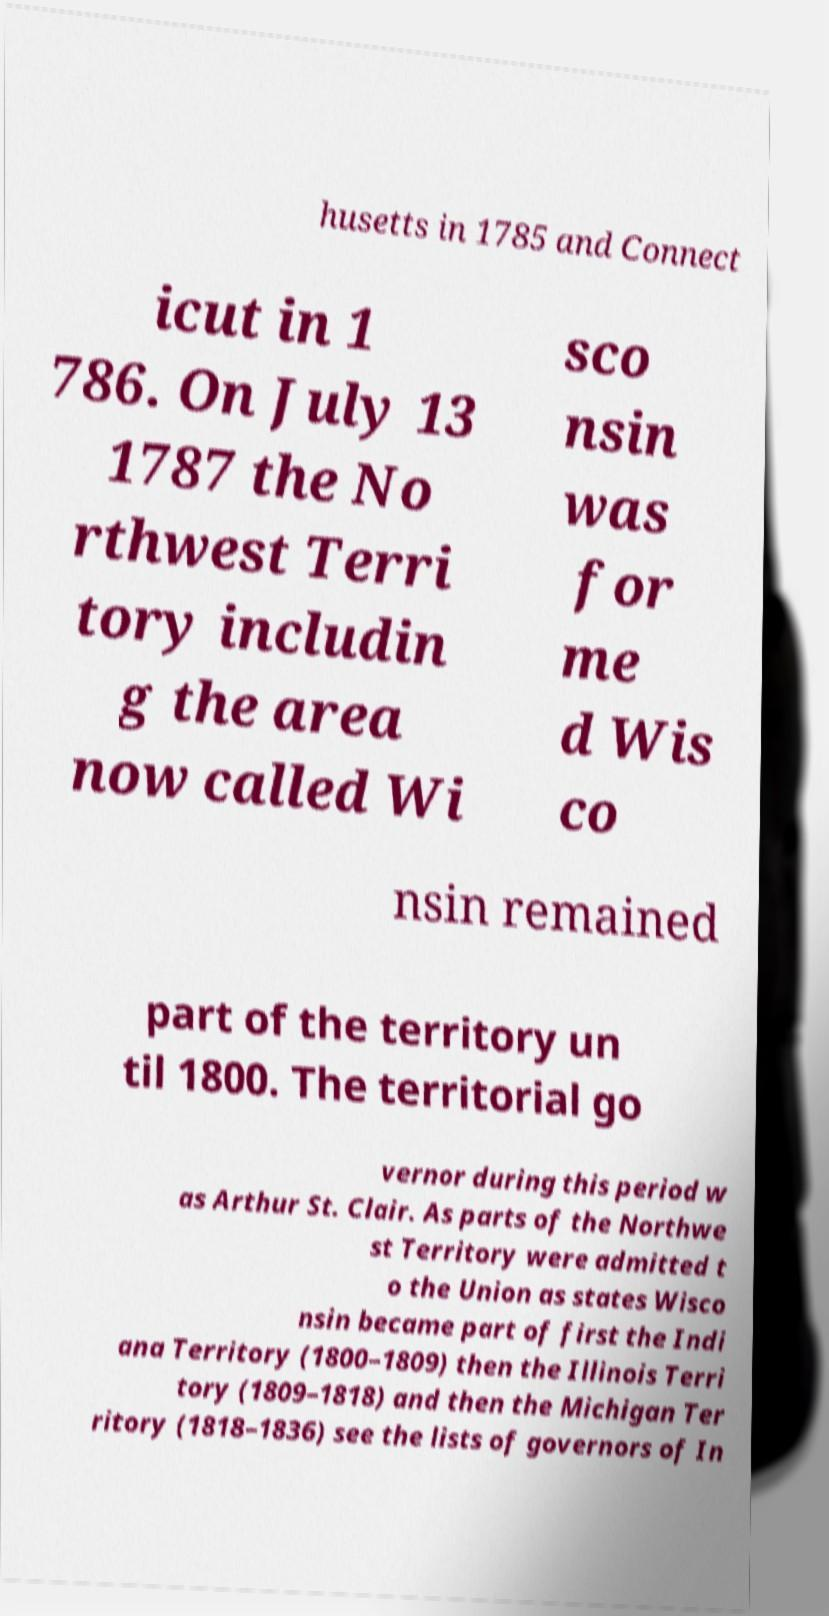For documentation purposes, I need the text within this image transcribed. Could you provide that? husetts in 1785 and Connect icut in 1 786. On July 13 1787 the No rthwest Terri tory includin g the area now called Wi sco nsin was for me d Wis co nsin remained part of the territory un til 1800. The territorial go vernor during this period w as Arthur St. Clair. As parts of the Northwe st Territory were admitted t o the Union as states Wisco nsin became part of first the Indi ana Territory (1800–1809) then the Illinois Terri tory (1809–1818) and then the Michigan Ter ritory (1818–1836) see the lists of governors of In 